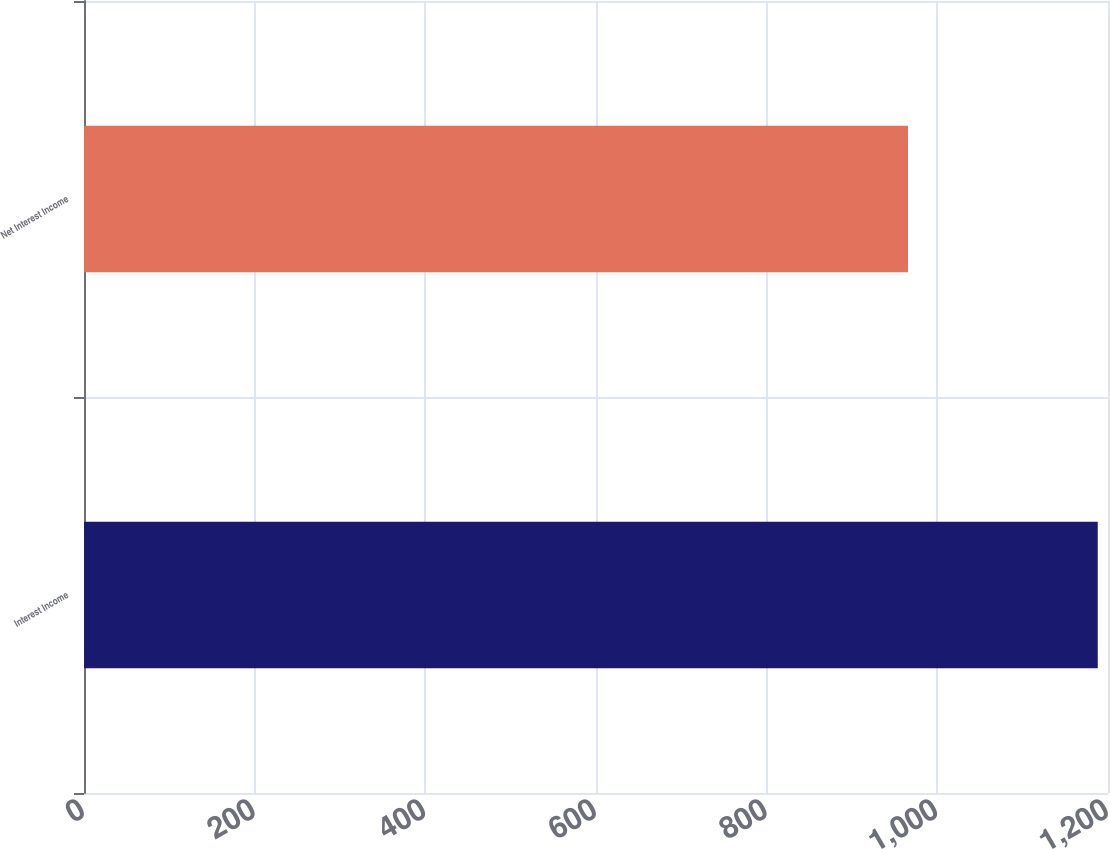Convert chart to OTSL. <chart><loc_0><loc_0><loc_500><loc_500><bar_chart><fcel>Interest Income<fcel>Net Interest Income<nl><fcel>1188<fcel>965.6<nl></chart> 